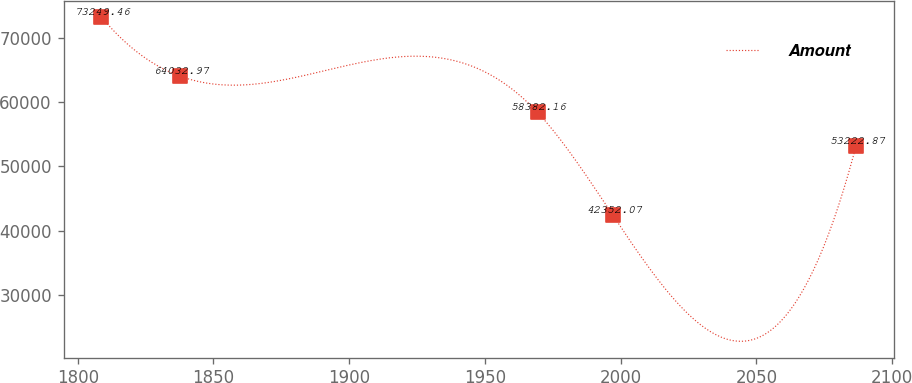Convert chart to OTSL. <chart><loc_0><loc_0><loc_500><loc_500><line_chart><ecel><fcel>Amount<nl><fcel>1808.66<fcel>73249.5<nl><fcel>1837.62<fcel>64033<nl><fcel>1969.39<fcel>58382.2<nl><fcel>1997.2<fcel>42352.1<nl><fcel>2086.78<fcel>53222.9<nl></chart> 